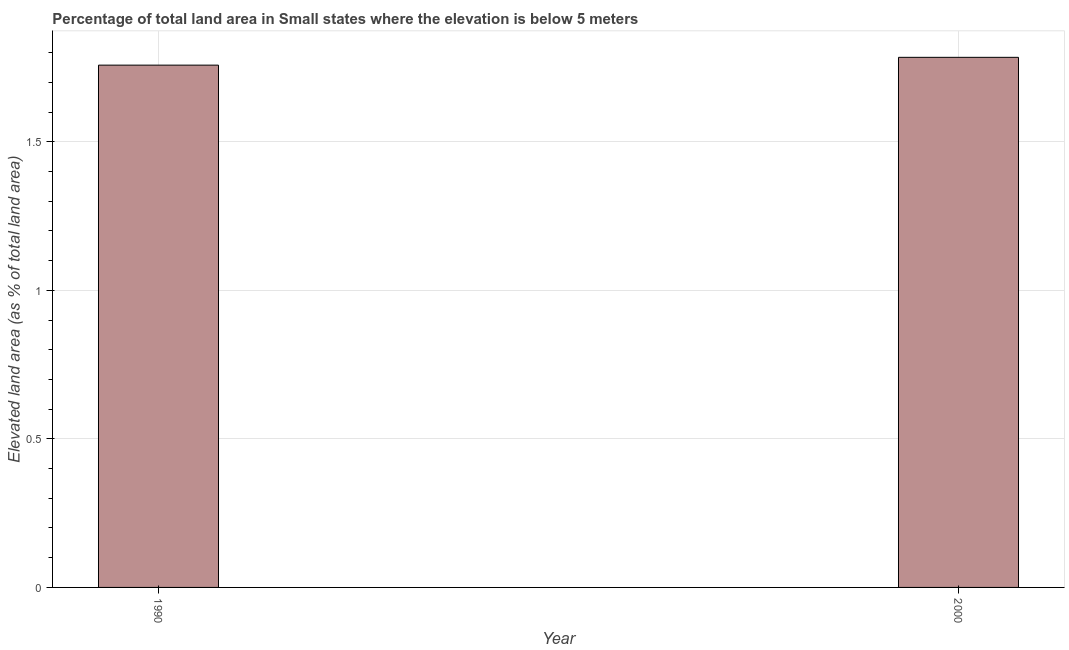Does the graph contain any zero values?
Provide a succinct answer. No. Does the graph contain grids?
Offer a very short reply. Yes. What is the title of the graph?
Your answer should be very brief. Percentage of total land area in Small states where the elevation is below 5 meters. What is the label or title of the X-axis?
Keep it short and to the point. Year. What is the label or title of the Y-axis?
Keep it short and to the point. Elevated land area (as % of total land area). What is the total elevated land area in 2000?
Offer a very short reply. 1.78. Across all years, what is the maximum total elevated land area?
Your answer should be compact. 1.78. Across all years, what is the minimum total elevated land area?
Offer a terse response. 1.76. In which year was the total elevated land area minimum?
Keep it short and to the point. 1990. What is the sum of the total elevated land area?
Provide a succinct answer. 3.54. What is the difference between the total elevated land area in 1990 and 2000?
Ensure brevity in your answer.  -0.03. What is the average total elevated land area per year?
Provide a succinct answer. 1.77. What is the median total elevated land area?
Your response must be concise. 1.77. In how many years, is the total elevated land area greater than 1.1 %?
Your answer should be very brief. 2. Do a majority of the years between 1990 and 2000 (inclusive) have total elevated land area greater than 1.7 %?
Provide a succinct answer. Yes. What is the ratio of the total elevated land area in 1990 to that in 2000?
Provide a succinct answer. 0.98. How many bars are there?
Ensure brevity in your answer.  2. How many years are there in the graph?
Keep it short and to the point. 2. What is the difference between two consecutive major ticks on the Y-axis?
Your response must be concise. 0.5. What is the Elevated land area (as % of total land area) of 1990?
Provide a succinct answer. 1.76. What is the Elevated land area (as % of total land area) of 2000?
Offer a terse response. 1.78. What is the difference between the Elevated land area (as % of total land area) in 1990 and 2000?
Your answer should be compact. -0.03. What is the ratio of the Elevated land area (as % of total land area) in 1990 to that in 2000?
Offer a very short reply. 0.98. 